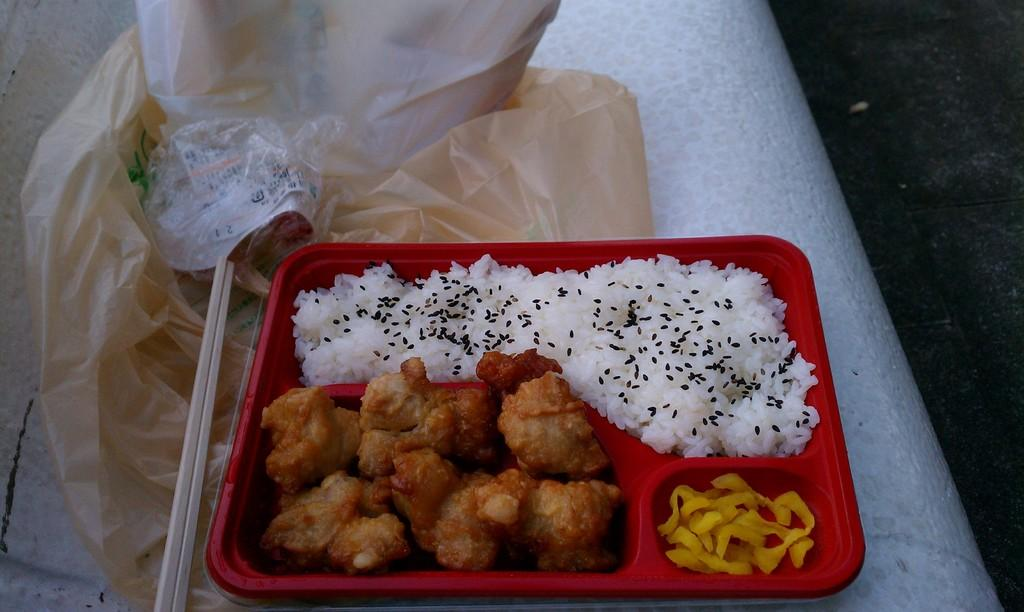What is the color of the surface in the image? The surface in the image is white. What is placed on the surface? There is a plate with food in the image. What type of food can be seen on the plate? The food includes fried snacks. What else is visible in the image besides the food and surface? There are polythene covers visible in the image. What scientific discovery is being made in the image? There is no scientific discovery being made in the image; it simply shows a plate of fried snacks on a white surface with polythene covers nearby. 